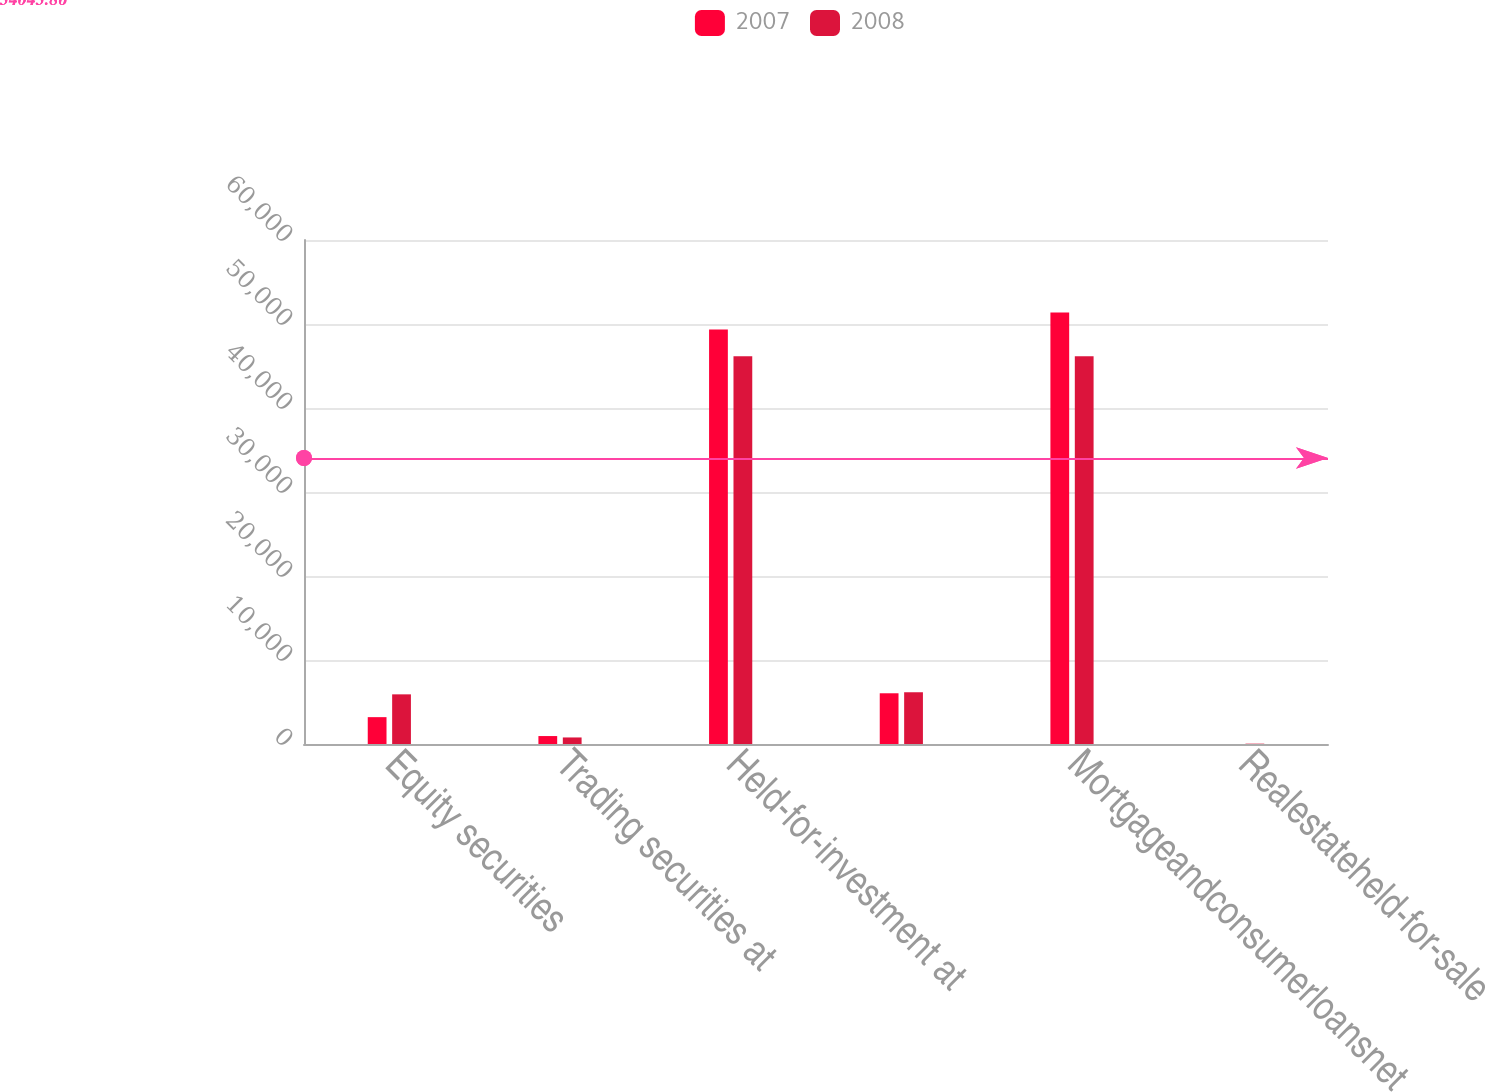Convert chart to OTSL. <chart><loc_0><loc_0><loc_500><loc_500><stacked_bar_chart><ecel><fcel>Equity securities<fcel>Trading securities at<fcel>Held-for-investment at<fcel>Unnamed: 4<fcel>Mortgageandconsumerloansnet<fcel>Realestateheld-for-sale<nl><fcel>2007<fcel>3197<fcel>946<fcel>49352<fcel>6039<fcel>51364<fcel>1<nl><fcel>2008<fcel>5911<fcel>779<fcel>46149<fcel>6155<fcel>46154<fcel>39<nl></chart> 